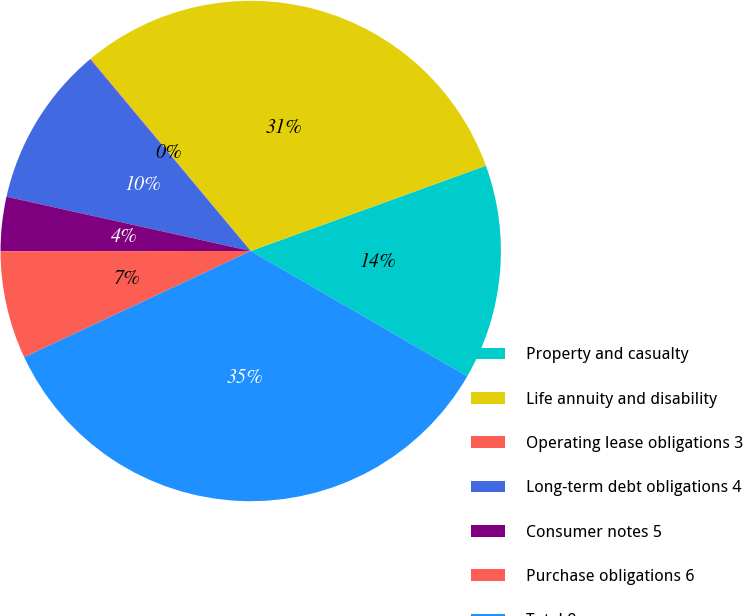Convert chart. <chart><loc_0><loc_0><loc_500><loc_500><pie_chart><fcel>Property and casualty<fcel>Life annuity and disability<fcel>Operating lease obligations 3<fcel>Long-term debt obligations 4<fcel>Consumer notes 5<fcel>Purchase obligations 6<fcel>Total 8<nl><fcel>13.89%<fcel>30.51%<fcel>0.04%<fcel>10.43%<fcel>3.5%<fcel>6.96%<fcel>34.67%<nl></chart> 